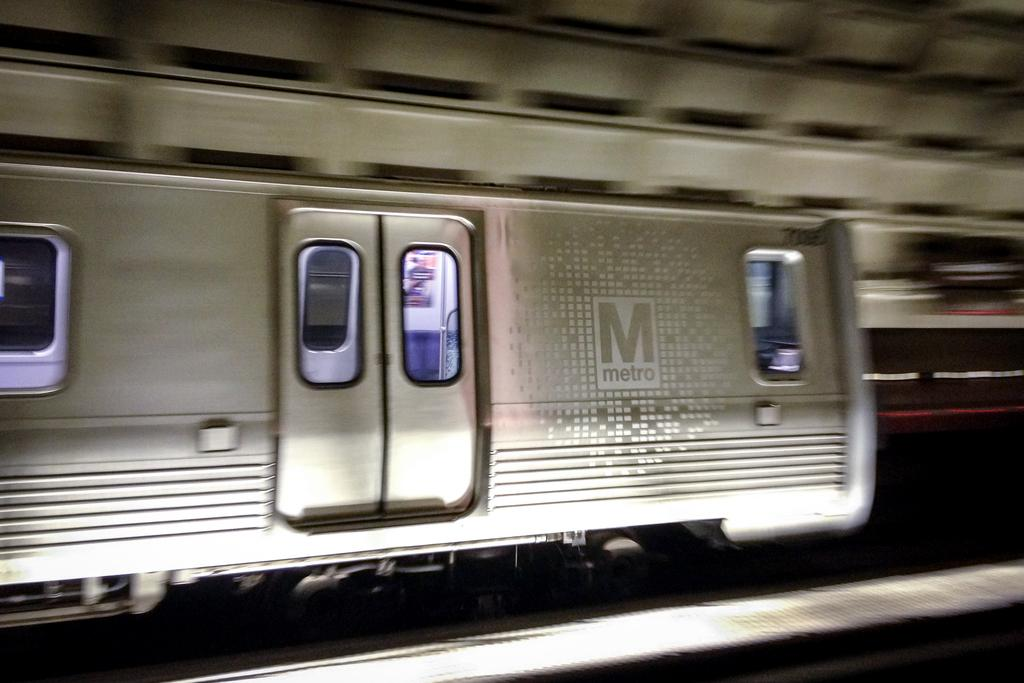<image>
Offer a succinct explanation of the picture presented. A silver Metro train speeds down the track. 